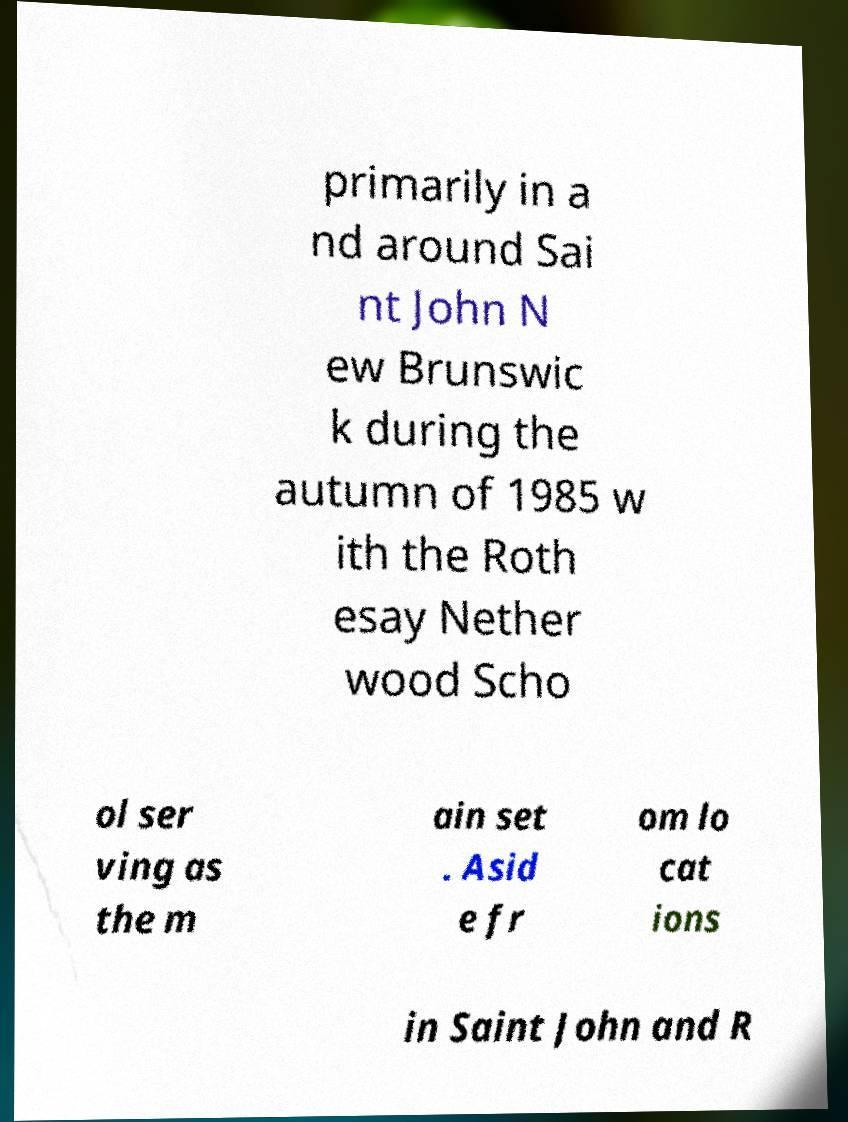I need the written content from this picture converted into text. Can you do that? primarily in a nd around Sai nt John N ew Brunswic k during the autumn of 1985 w ith the Roth esay Nether wood Scho ol ser ving as the m ain set . Asid e fr om lo cat ions in Saint John and R 